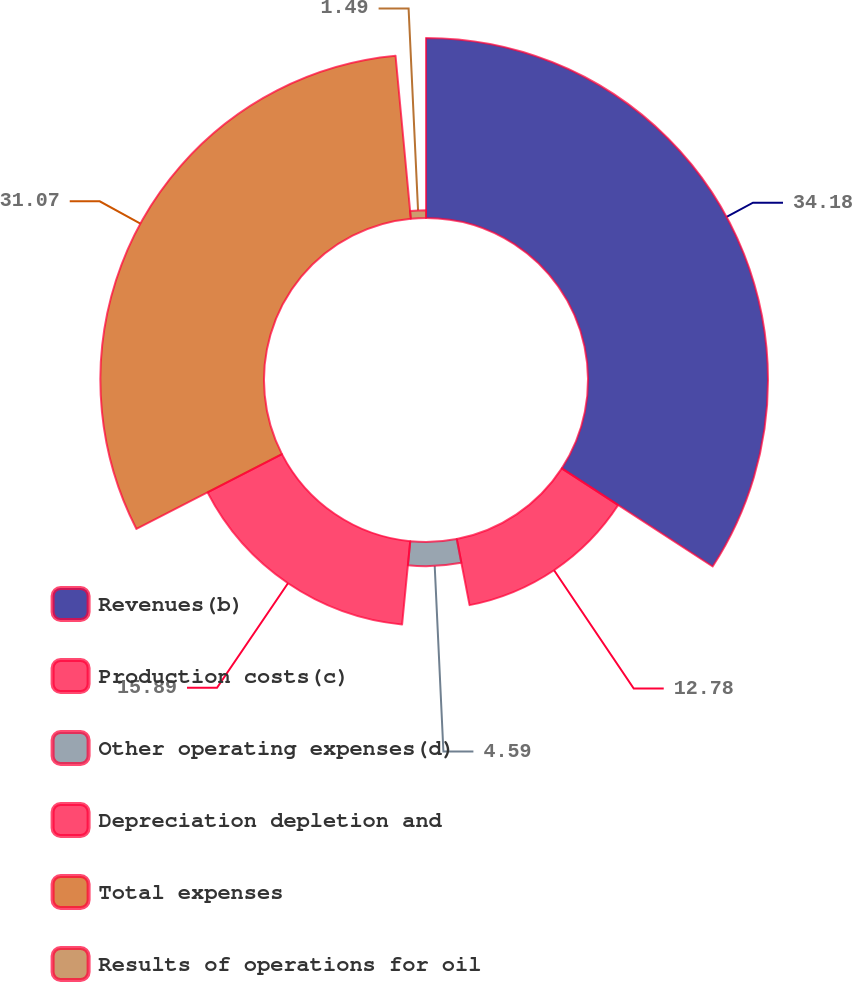Convert chart. <chart><loc_0><loc_0><loc_500><loc_500><pie_chart><fcel>Revenues(b)<fcel>Production costs(c)<fcel>Other operating expenses(d)<fcel>Depreciation depletion and<fcel>Total expenses<fcel>Results of operations for oil<nl><fcel>34.18%<fcel>12.78%<fcel>4.59%<fcel>15.89%<fcel>31.07%<fcel>1.49%<nl></chart> 